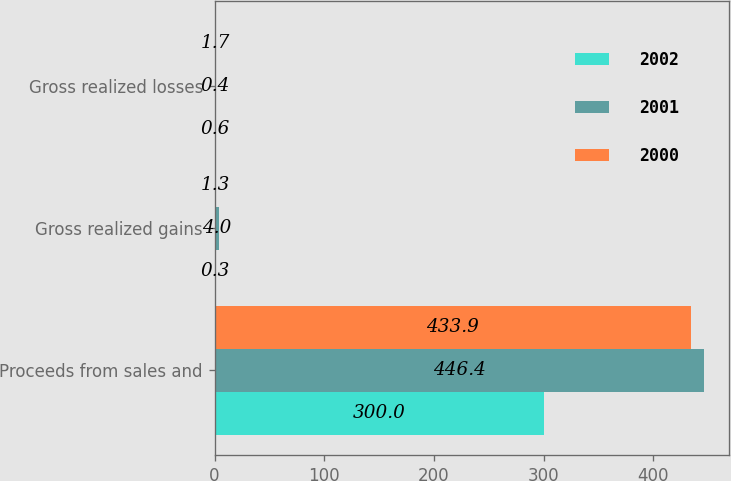Convert chart. <chart><loc_0><loc_0><loc_500><loc_500><stacked_bar_chart><ecel><fcel>Proceeds from sales and<fcel>Gross realized gains<fcel>Gross realized losses<nl><fcel>2002<fcel>300<fcel>0.3<fcel>0.6<nl><fcel>2001<fcel>446.4<fcel>4<fcel>0.4<nl><fcel>2000<fcel>433.9<fcel>1.3<fcel>1.7<nl></chart> 